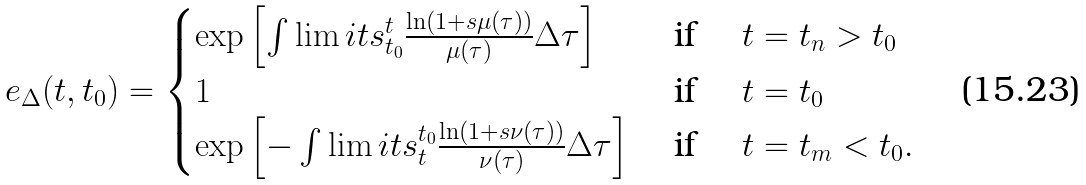<formula> <loc_0><loc_0><loc_500><loc_500>e _ { \Delta } ( t , t _ { 0 } ) = \begin{cases} \exp \left [ \int \lim i t s _ { t _ { 0 } } ^ { t } \frac { \ln \left ( 1 + s \mu ( \tau ) \right ) } { \mu ( \tau ) } \Delta \tau \right ] & \text { if } \quad t = t _ { n } > t _ { 0 } \\ 1 & \text { if } \quad t = t _ { 0 } \\ \exp \left [ - \int \lim i t s _ { t } ^ { t _ { 0 } } \frac { \ln \left ( 1 + s \nu ( \tau ) \right ) } { \nu ( \tau ) } \Delta \tau \right ] & \text { if } \quad t = t _ { m } < t _ { 0 } . \end{cases}</formula> 